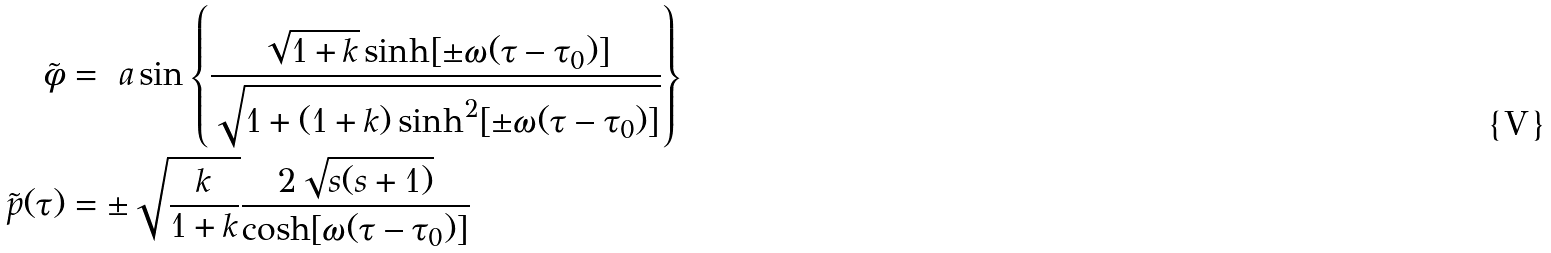Convert formula to latex. <formula><loc_0><loc_0><loc_500><loc_500>\tilde { \phi } & = \ a \sin \left \{ \frac { \sqrt { 1 + k } \sinh [ \pm \omega ( \tau - \tau _ { 0 } ) ] } { \sqrt { 1 + ( 1 + k ) \sinh ^ { 2 } [ \pm \omega ( \tau - \tau _ { 0 } ) ] } } \right \} \\ \tilde { p } ( \tau ) & = \pm \sqrt { \frac { k } { 1 + k } } \frac { 2 \sqrt { s ( s + 1 ) } } { \cosh [ \omega ( \tau - \tau _ { 0 } ) ] }</formula> 